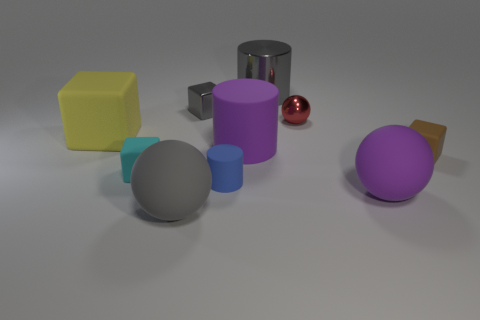Subtract all balls. How many objects are left? 7 Add 1 large blue metallic things. How many large blue metallic things exist? 1 Subtract 1 brown cubes. How many objects are left? 9 Subtract all tiny brown things. Subtract all purple cylinders. How many objects are left? 8 Add 8 brown things. How many brown things are left? 9 